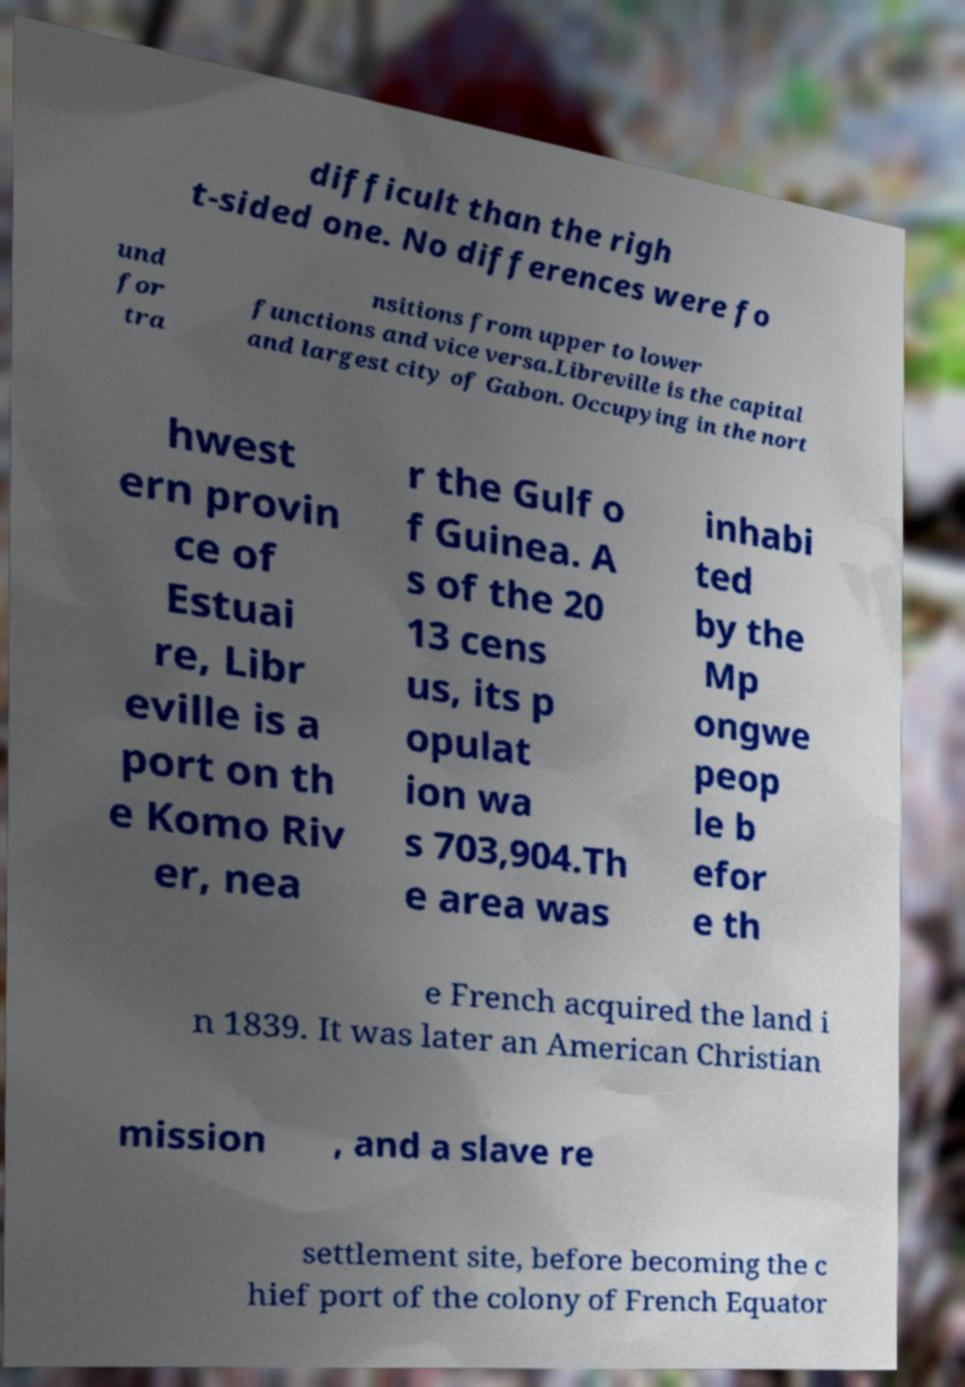Can you read and provide the text displayed in the image?This photo seems to have some interesting text. Can you extract and type it out for me? difficult than the righ t-sided one. No differences were fo und for tra nsitions from upper to lower functions and vice versa.Libreville is the capital and largest city of Gabon. Occupying in the nort hwest ern provin ce of Estuai re, Libr eville is a port on th e Komo Riv er, nea r the Gulf o f Guinea. A s of the 20 13 cens us, its p opulat ion wa s 703,904.Th e area was inhabi ted by the Mp ongwe peop le b efor e th e French acquired the land i n 1839. It was later an American Christian mission , and a slave re settlement site, before becoming the c hief port of the colony of French Equator 